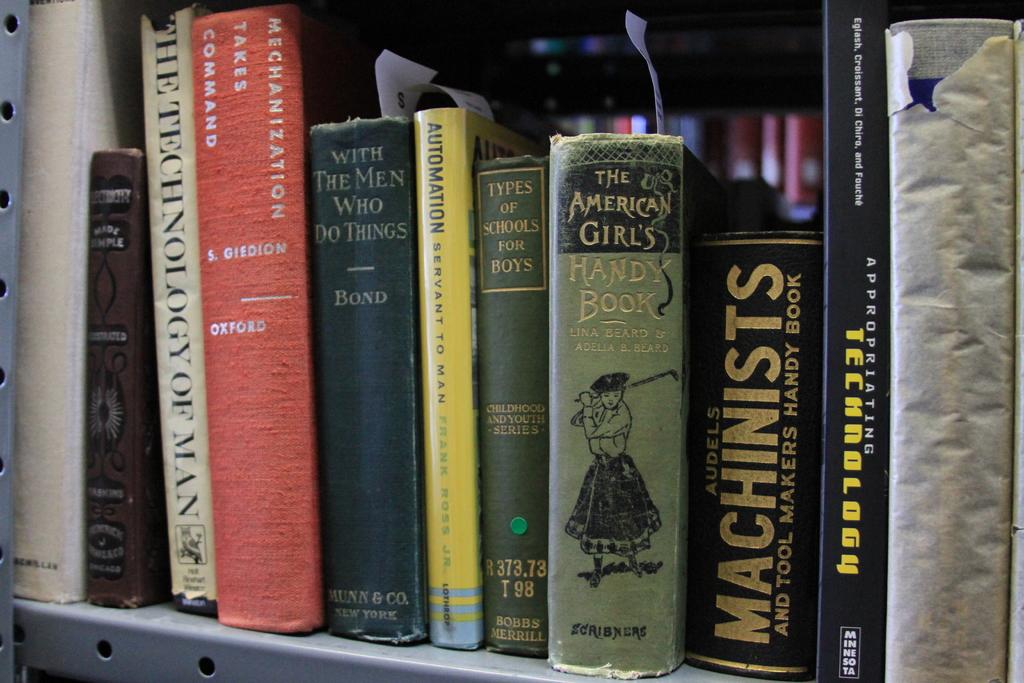What is the name of the book with the girl on it?
Provide a succinct answer. The american girl's handy book. 